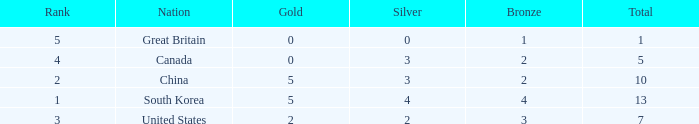What is the total number of Gold, when Silver is 2, and when Total is less than 7? 0.0. 